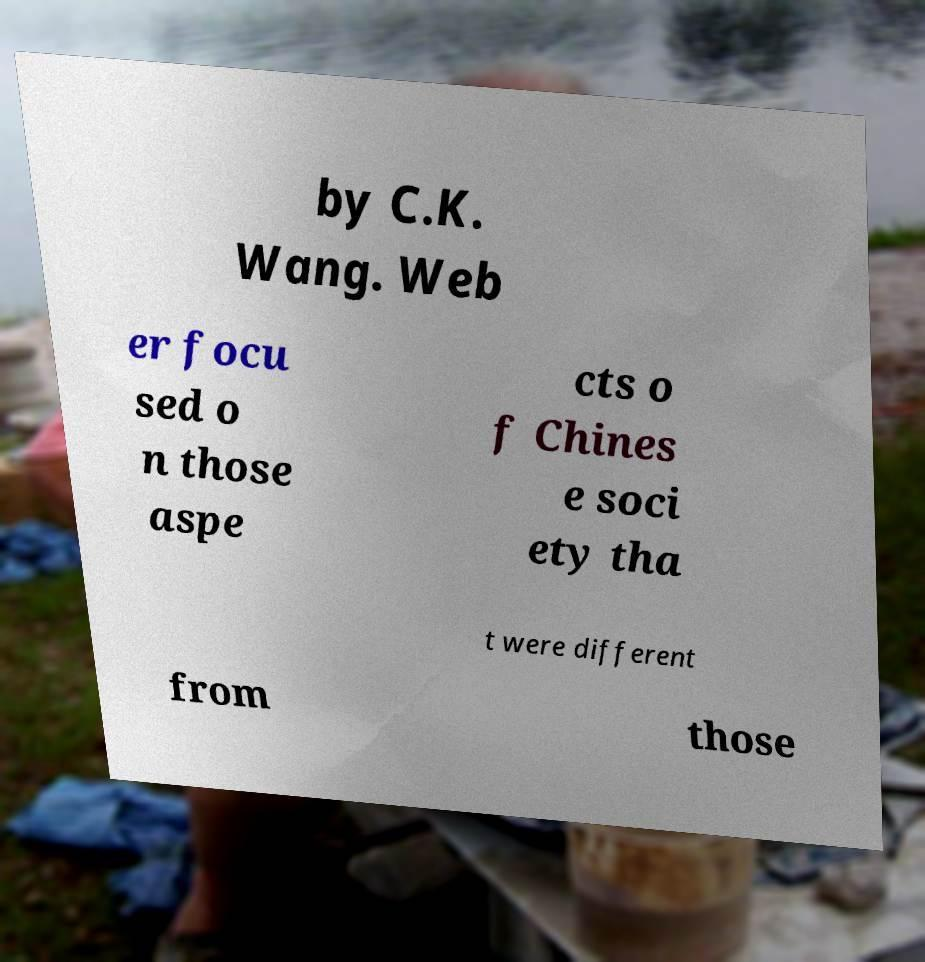Can you read and provide the text displayed in the image?This photo seems to have some interesting text. Can you extract and type it out for me? by C.K. Wang. Web er focu sed o n those aspe cts o f Chines e soci ety tha t were different from those 